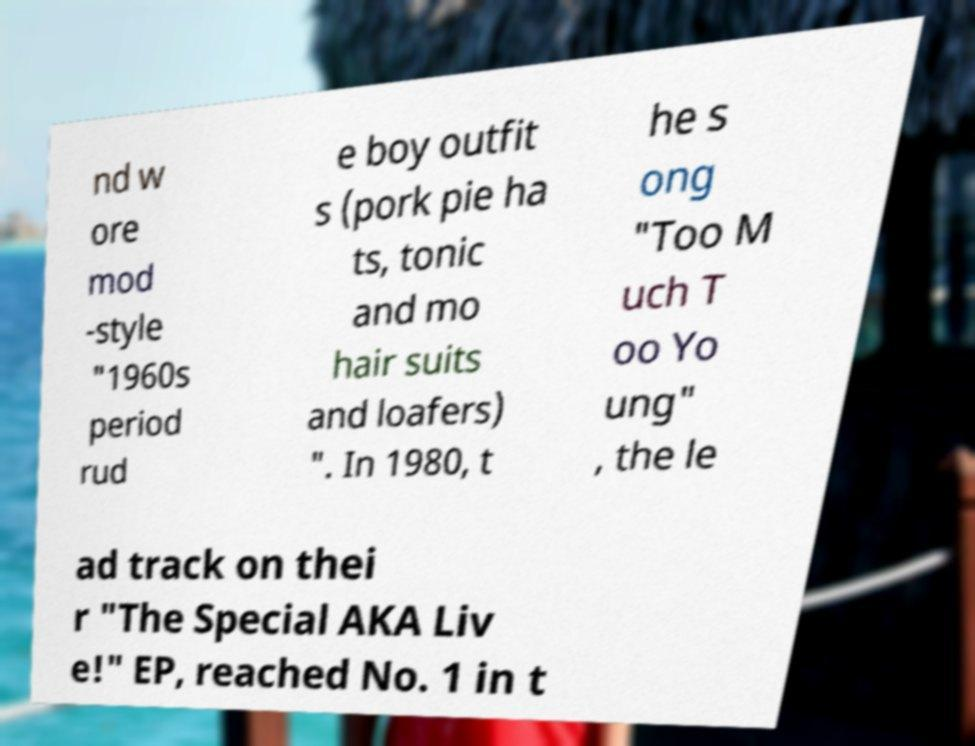For documentation purposes, I need the text within this image transcribed. Could you provide that? nd w ore mod -style "1960s period rud e boy outfit s (pork pie ha ts, tonic and mo hair suits and loafers) ". In 1980, t he s ong "Too M uch T oo Yo ung" , the le ad track on thei r "The Special AKA Liv e!" EP, reached No. 1 in t 